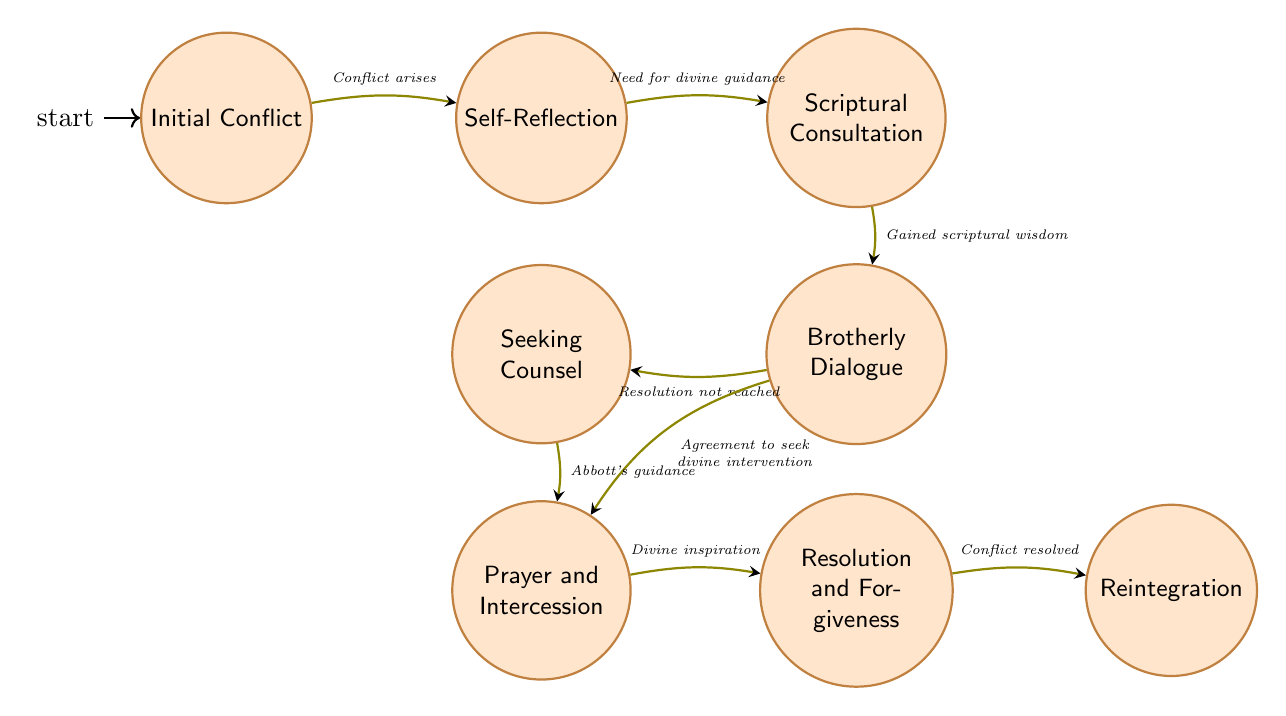What is the initial state of the conflict resolution process? The initial state, as indicated in the diagram, is "Initial Conflict." This is where the process begins upon the occurrence of a misunderstanding or disagreement among the monks.
Answer: Initial Conflict How many nodes are present in the diagram? The diagram contains a total of 8 nodes that represent different states in the conflict resolution process. The states are distinct aspects that the monks go through.
Answer: 8 What is the transition that occurs after 'Self-Reflection'? After 'Self-Reflection,' the transition occurs to 'Scriptural Consultation.' This transition is triggered when monks feel the need for divine guidance in resolving their conflict.
Answer: Scriptural Consultation Which state follows 'Prayer and Intercession'? The state that follows 'Prayer and Intercession' is 'Resolution and Forgiveness.' This transition occurs when monks receive divine inspiration to resolve their conflict.
Answer: Resolution and Forgiveness What triggers the transition from 'Brotherly Dialogue' to 'Seeking Counsel'? The transition from 'Brotherly Dialogue' to 'Seeking Counsel' is triggered when the monks conclude that a resolution has not been reached through their dialogue. This indicates a need for further assistance.
Answer: Resolution not reached Which state is reached after the conflict is resolved? After the conflict is resolved, the next state reached is 'Reintegration.' This occurs as monks reintegrate into communal activities following the resolution and forgiveness process.
Answer: Reintegration What scripture is consulted during 'Scriptural Consultation'? During 'Scriptural Consultation,' the monks read and meditate on Scriptures, specifically Matthew 18:15-17 and Proverbs 15:1, for guidance and wisdom on the conflict.
Answer: Matthew 18:15-17 and Proverbs 15:1 What is required for monks to move from ‘Seeking Counsel’ to ‘Prayer and Intercession’? For monks to move from ‘Seeking Counsel’ to ‘Prayer and Intercession,’ the trigger is 'Abbott's guidance.' This implies that the abbott's counsel guides them to collectively pray for resolution.
Answer: Abbott's guidance 